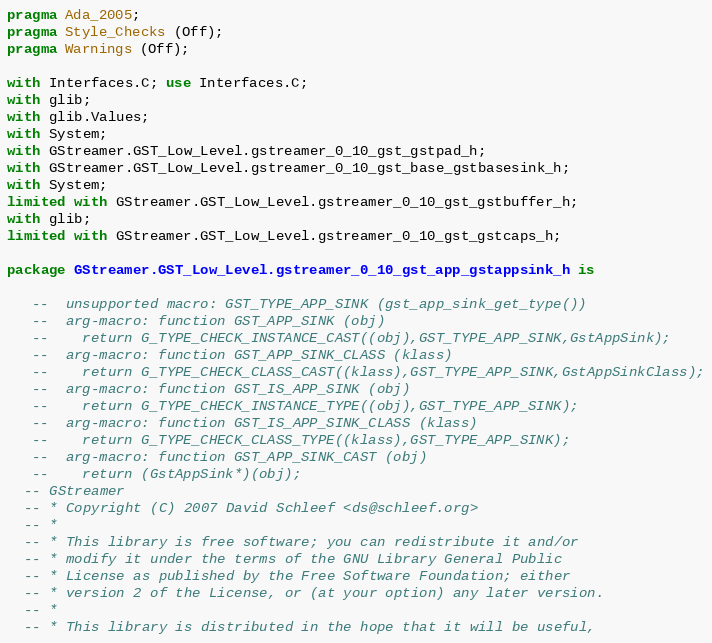Convert code to text. <code><loc_0><loc_0><loc_500><loc_500><_Ada_>pragma Ada_2005;
pragma Style_Checks (Off);
pragma Warnings (Off);

with Interfaces.C; use Interfaces.C;
with glib;
with glib.Values;
with System;
with GStreamer.GST_Low_Level.gstreamer_0_10_gst_gstpad_h;
with GStreamer.GST_Low_Level.gstreamer_0_10_gst_base_gstbasesink_h;
with System;
limited with GStreamer.GST_Low_Level.gstreamer_0_10_gst_gstbuffer_h;
with glib;
limited with GStreamer.GST_Low_Level.gstreamer_0_10_gst_gstcaps_h;

package GStreamer.GST_Low_Level.gstreamer_0_10_gst_app_gstappsink_h is

   --  unsupported macro: GST_TYPE_APP_SINK (gst_app_sink_get_type())
   --  arg-macro: function GST_APP_SINK (obj)
   --    return G_TYPE_CHECK_INSTANCE_CAST((obj),GST_TYPE_APP_SINK,GstAppSink);
   --  arg-macro: function GST_APP_SINK_CLASS (klass)
   --    return G_TYPE_CHECK_CLASS_CAST((klass),GST_TYPE_APP_SINK,GstAppSinkClass);
   --  arg-macro: function GST_IS_APP_SINK (obj)
   --    return G_TYPE_CHECK_INSTANCE_TYPE((obj),GST_TYPE_APP_SINK);
   --  arg-macro: function GST_IS_APP_SINK_CLASS (klass)
   --    return G_TYPE_CHECK_CLASS_TYPE((klass),GST_TYPE_APP_SINK);
   --  arg-macro: function GST_APP_SINK_CAST (obj)
   --    return (GstAppSink*)(obj);
  -- GStreamer
  -- * Copyright (C) 2007 David Schleef <ds@schleef.org>
  -- *
  -- * This library is free software; you can redistribute it and/or
  -- * modify it under the terms of the GNU Library General Public
  -- * License as published by the Free Software Foundation; either
  -- * version 2 of the License, or (at your option) any later version.
  -- *
  -- * This library is distributed in the hope that it will be useful,</code> 